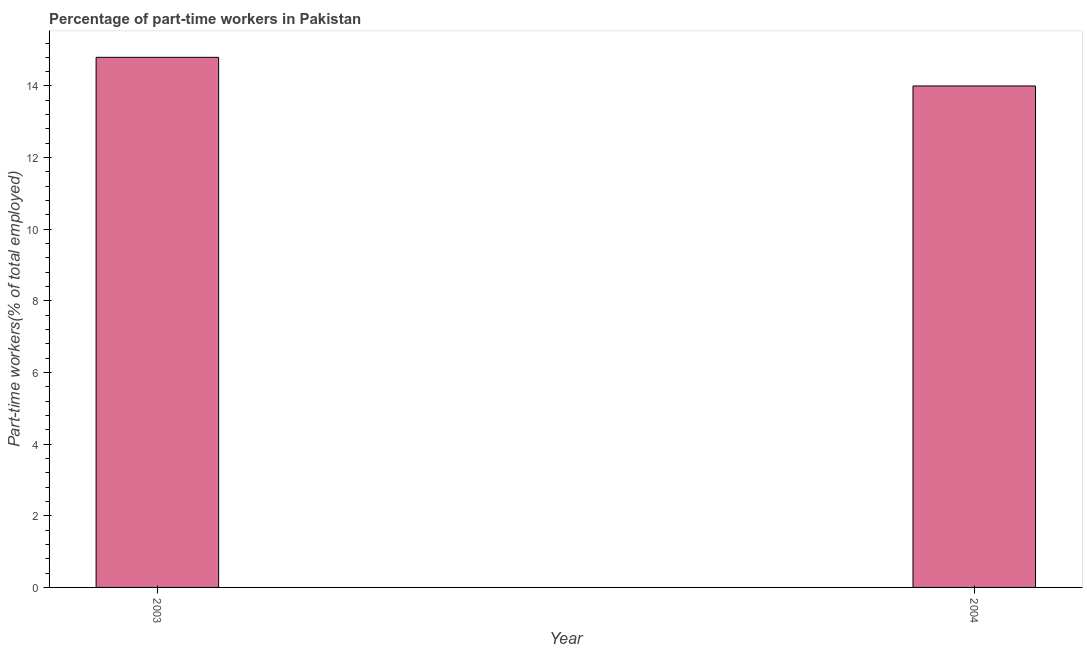Does the graph contain any zero values?
Give a very brief answer. No. What is the title of the graph?
Ensure brevity in your answer.  Percentage of part-time workers in Pakistan. What is the label or title of the Y-axis?
Your answer should be very brief. Part-time workers(% of total employed). What is the percentage of part-time workers in 2003?
Keep it short and to the point. 14.8. Across all years, what is the maximum percentage of part-time workers?
Your answer should be very brief. 14.8. Across all years, what is the minimum percentage of part-time workers?
Give a very brief answer. 14. In which year was the percentage of part-time workers maximum?
Your answer should be very brief. 2003. In which year was the percentage of part-time workers minimum?
Offer a very short reply. 2004. What is the sum of the percentage of part-time workers?
Provide a short and direct response. 28.8. What is the difference between the percentage of part-time workers in 2003 and 2004?
Provide a short and direct response. 0.8. What is the median percentage of part-time workers?
Keep it short and to the point. 14.4. Do a majority of the years between 2003 and 2004 (inclusive) have percentage of part-time workers greater than 10.4 %?
Provide a short and direct response. Yes. What is the ratio of the percentage of part-time workers in 2003 to that in 2004?
Give a very brief answer. 1.06. Is the percentage of part-time workers in 2003 less than that in 2004?
Give a very brief answer. No. In how many years, is the percentage of part-time workers greater than the average percentage of part-time workers taken over all years?
Keep it short and to the point. 1. How many bars are there?
Ensure brevity in your answer.  2. Are all the bars in the graph horizontal?
Your answer should be very brief. No. What is the difference between two consecutive major ticks on the Y-axis?
Your response must be concise. 2. What is the Part-time workers(% of total employed) of 2003?
Offer a terse response. 14.8. What is the ratio of the Part-time workers(% of total employed) in 2003 to that in 2004?
Your answer should be compact. 1.06. 